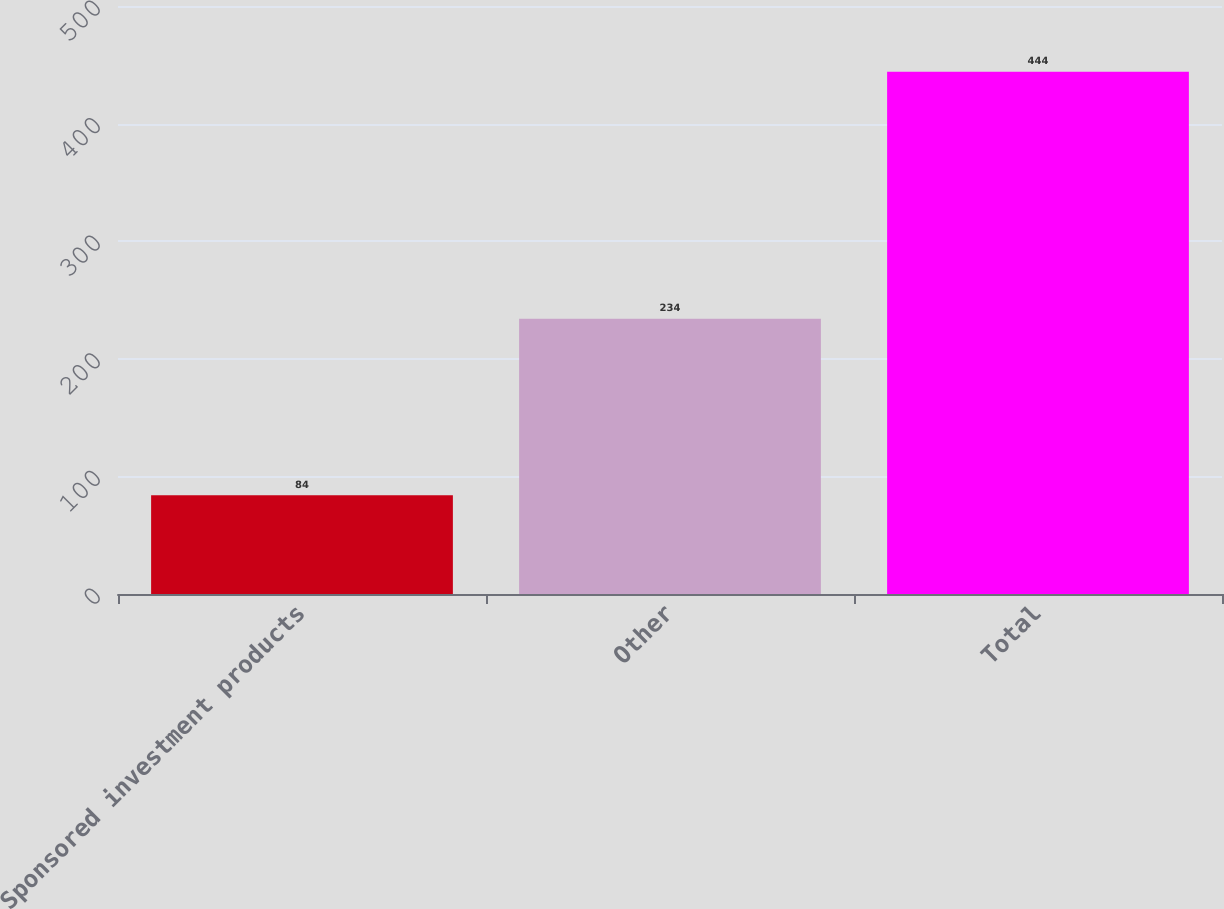Convert chart. <chart><loc_0><loc_0><loc_500><loc_500><bar_chart><fcel>Sponsored investment products<fcel>Other<fcel>Total<nl><fcel>84<fcel>234<fcel>444<nl></chart> 